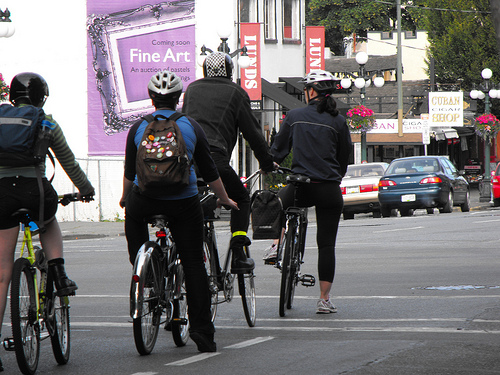<image>
Is the bike in front of the car? No. The bike is not in front of the car. The spatial positioning shows a different relationship between these objects. Is there a car to the left of the boy? No. The car is not to the left of the boy. From this viewpoint, they have a different horizontal relationship. 